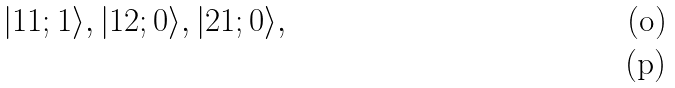<formula> <loc_0><loc_0><loc_500><loc_500>| 1 1 ; 1 \rangle , | 1 2 ; 0 \rangle , | 2 1 ; 0 \rangle , \\</formula> 